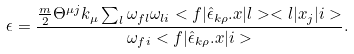Convert formula to latex. <formula><loc_0><loc_0><loc_500><loc_500>\epsilon = \frac { \frac { m } { 2 } \Theta ^ { \mu j } k _ { \mu } \sum _ { l } \omega _ { f l } \omega _ { l i } < f | \hat { \epsilon } _ { k \rho } . x | l > < l | x _ { j } | i > } { \omega _ { f i } < f | \hat { \epsilon } _ { k \rho } . x | i > } .</formula> 